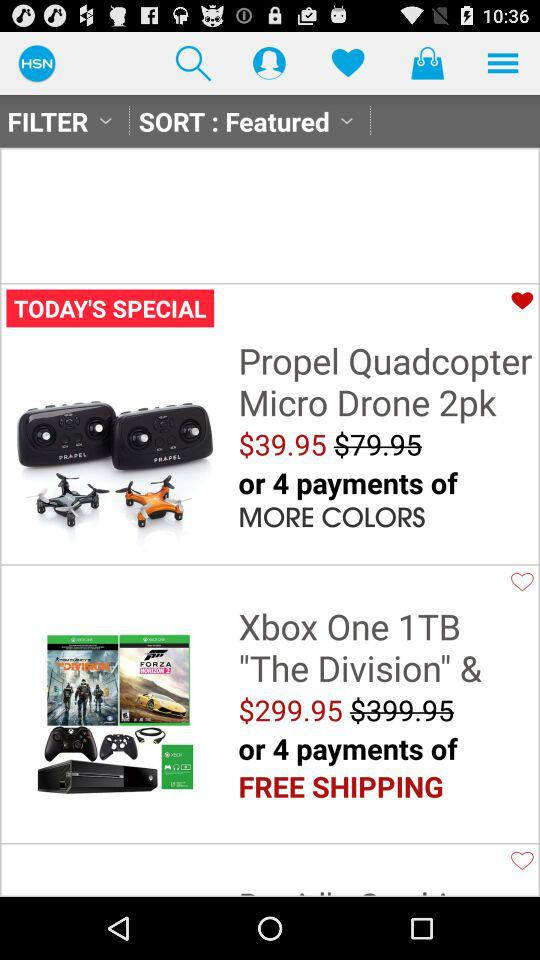What is the price of "Propel Quadcopter Micro Drone 2pk"? The price is $39.95. 